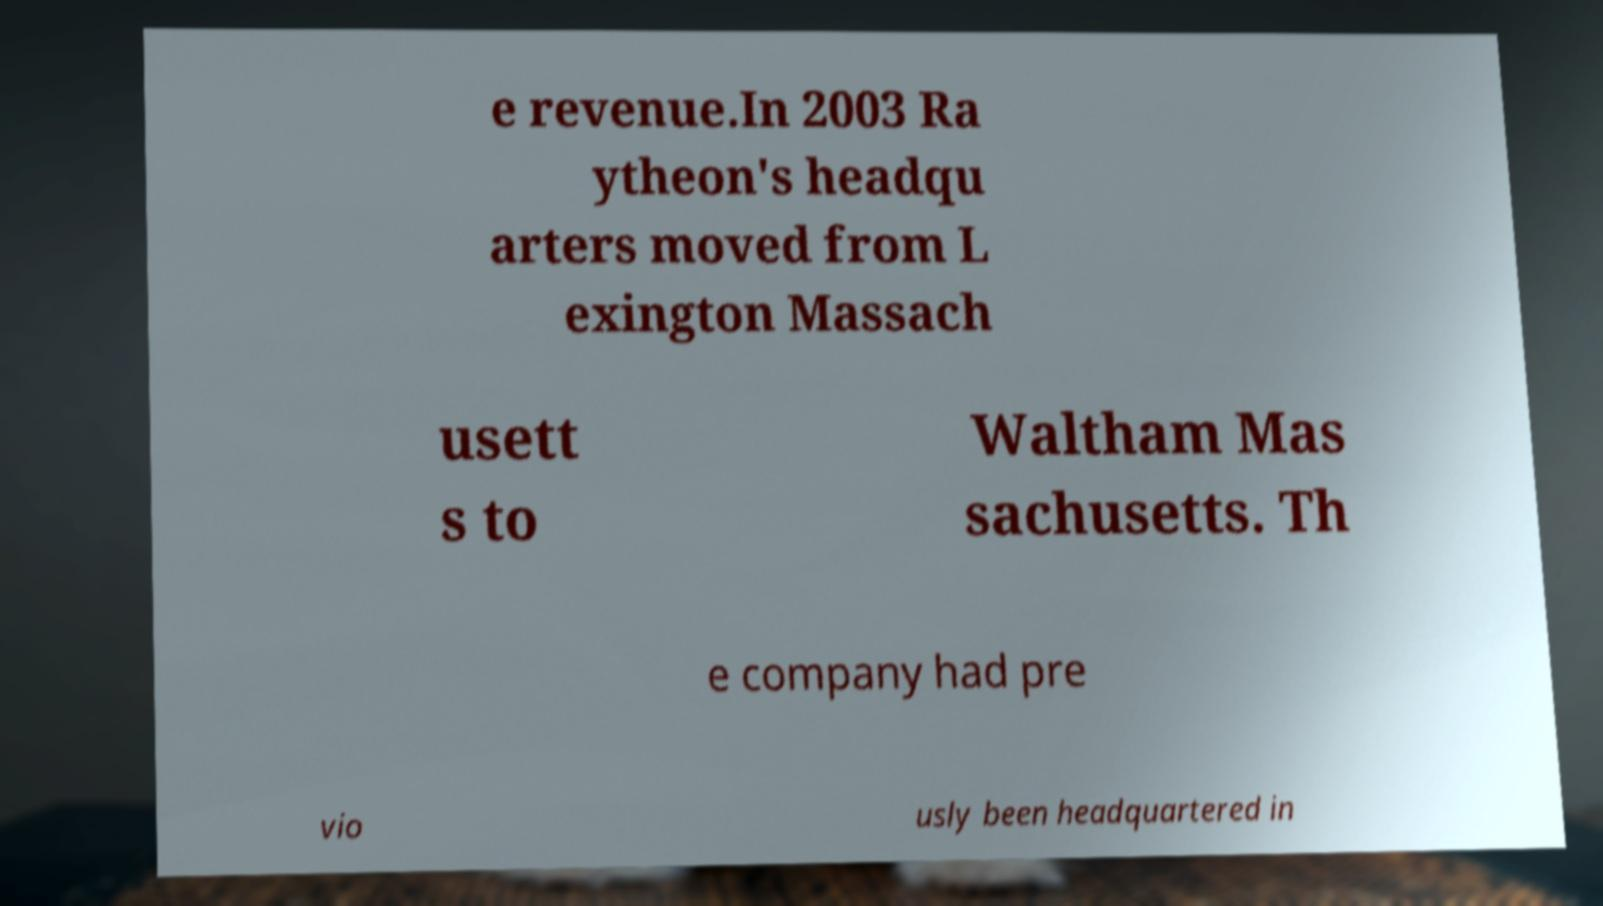Can you accurately transcribe the text from the provided image for me? e revenue.In 2003 Ra ytheon's headqu arters moved from L exington Massach usett s to Waltham Mas sachusetts. Th e company had pre vio usly been headquartered in 